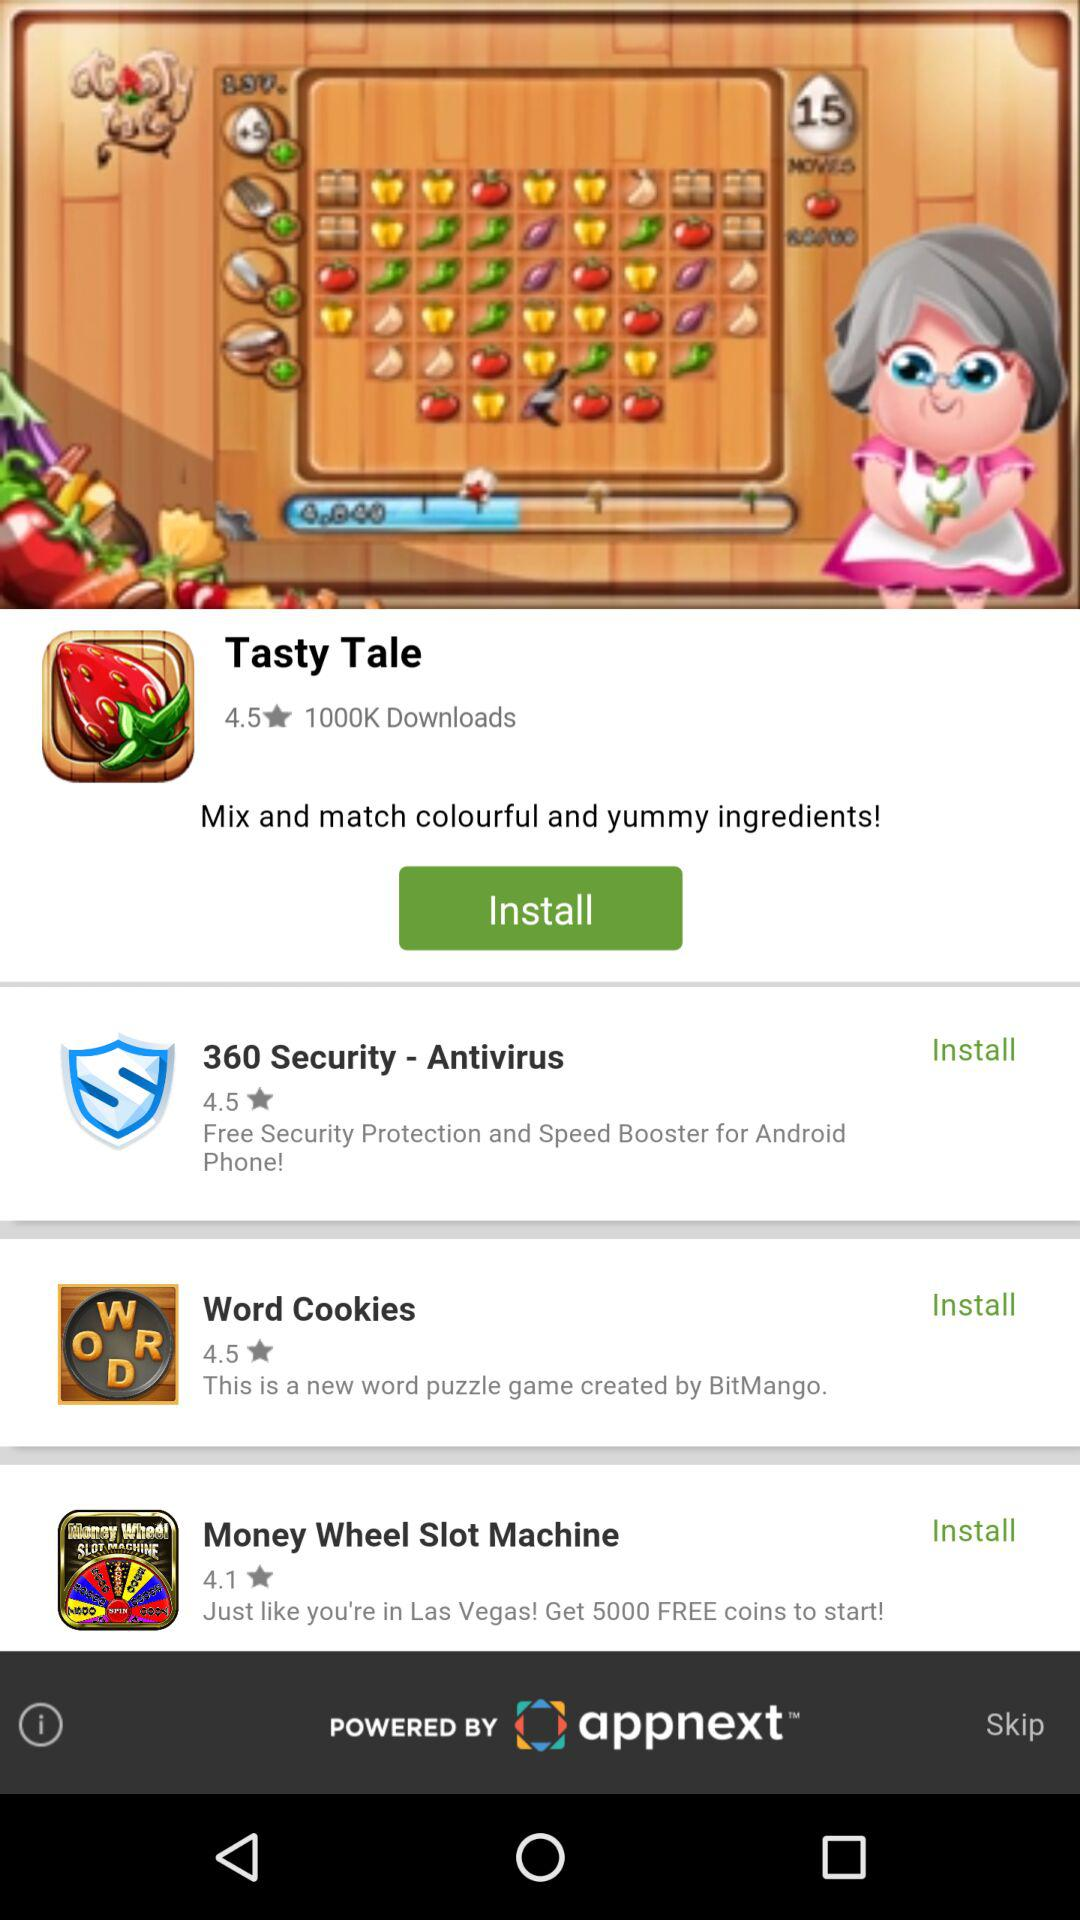How many games are rated 4.1 or lower?
Answer the question using a single word or phrase. 1 